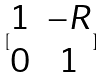<formula> <loc_0><loc_0><loc_500><loc_500>[ \begin{matrix} 1 & - R \\ 0 & 1 \end{matrix} ]</formula> 